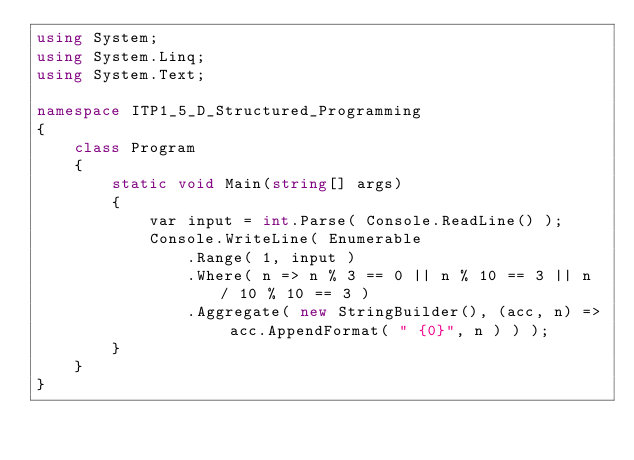<code> <loc_0><loc_0><loc_500><loc_500><_C#_>using System;
using System.Linq;
using System.Text;

namespace ITP1_5_D_Structured_Programming
{
    class Program
    {
        static void Main(string[] args)
        {
            var input = int.Parse( Console.ReadLine() );
            Console.WriteLine( Enumerable
                .Range( 1, input )
                .Where( n => n % 3 == 0 || n % 10 == 3 || n / 10 % 10 == 3 )
                .Aggregate( new StringBuilder(), (acc, n) => acc.AppendFormat( " {0}", n ) ) );
        }
    }
}</code> 